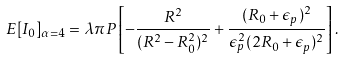<formula> <loc_0><loc_0><loc_500><loc_500>E [ I _ { 0 } ] _ { \alpha = 4 } & = \lambda \pi P \left [ - \frac { R ^ { 2 } } { ( R ^ { 2 } - R _ { 0 } ^ { 2 } ) ^ { 2 } } + \frac { ( R _ { 0 } + \epsilon _ { p } ) ^ { 2 } } { \epsilon _ { p } ^ { 2 } ( 2 R _ { 0 } + \epsilon _ { p } ) ^ { 2 } } \right ] .</formula> 